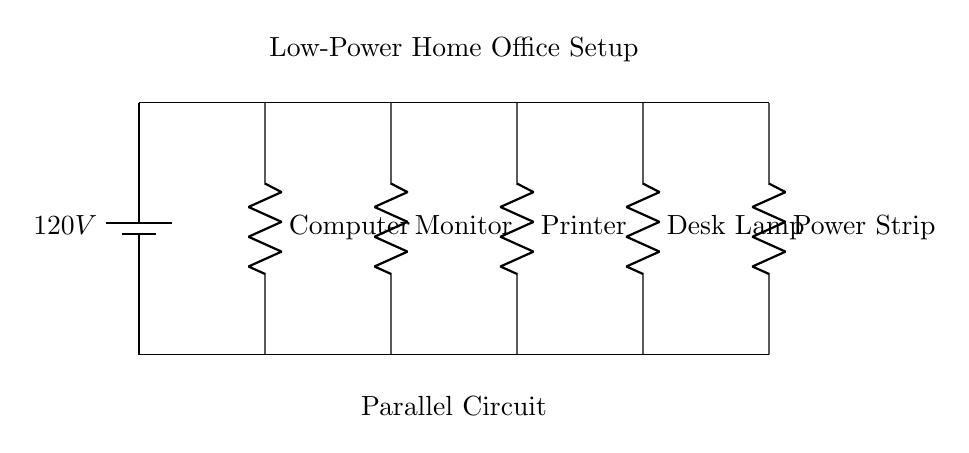What components are present in this circuit? The components visible in the circuit diagram include a computer, monitor, printer, desk lamp, and power strip, all connected in parallel.
Answer: Computer, Monitor, Printer, Desk Lamp, Power Strip What is the total voltage supplied to the circuit? The circuit consists of a battery that provides a voltage of 120 volts to all components connected in parallel.
Answer: 120 volts How many output devices are connected in this parallel setup? There are four output devices connected in this circuit: the computer, monitor, printer, and desk lamp.
Answer: Four What is the type of connection used in this circuit? The circuit uses a parallel connection, allowing each component to receive the same voltage while operating independently.
Answer: Parallel What would happen if one device fails in this parallel circuit? If one device fails, such as the printer, the remaining devices (computer, monitor, and desk lamp) would continue to operate normally because they are independently connected.
Answer: Remaining devices operate normally What is the advantage of using a parallel circuit for a home office setup? The advantage of a parallel circuit is that it allows each device to function independently, ensuring that one failure does not affect the others, which is essential for continuous operation in a home office environment.
Answer: Independent operation of devices 